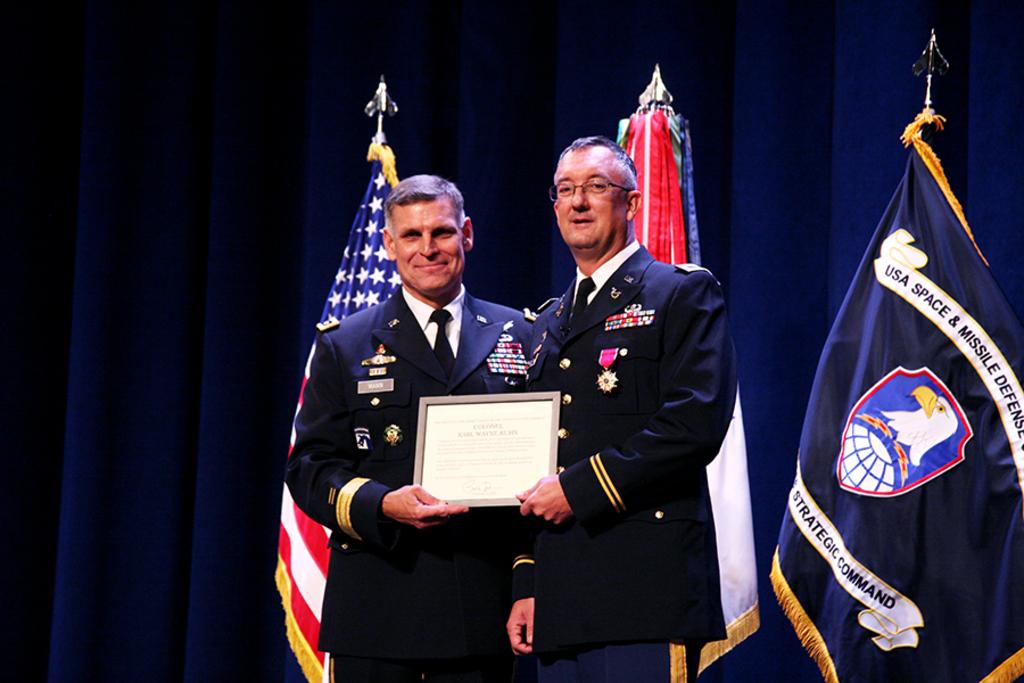What's the name on the flag on the right?
Your answer should be very brief. Usa space & missile defense. 